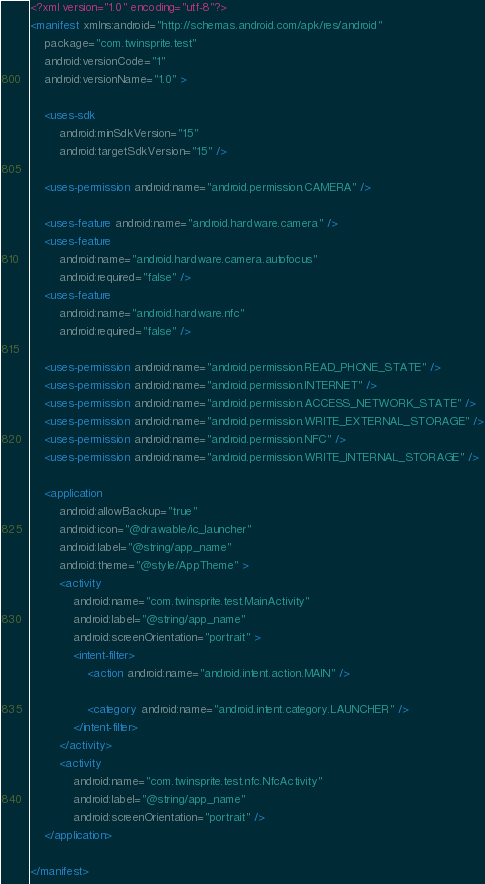<code> <loc_0><loc_0><loc_500><loc_500><_XML_><?xml version="1.0" encoding="utf-8"?>
<manifest xmlns:android="http://schemas.android.com/apk/res/android"
    package="com.twinsprite.test"
    android:versionCode="1"
    android:versionName="1.0" >

    <uses-sdk
        android:minSdkVersion="15"
        android:targetSdkVersion="15" />

    <uses-permission android:name="android.permission.CAMERA" />

    <uses-feature android:name="android.hardware.camera" />
    <uses-feature
        android:name="android.hardware.camera.autofocus"
        android:required="false" />
    <uses-feature
        android:name="android.hardware.nfc"
        android:required="false" />

    <uses-permission android:name="android.permission.READ_PHONE_STATE" />
    <uses-permission android:name="android.permission.INTERNET" />
    <uses-permission android:name="android.permission.ACCESS_NETWORK_STATE" />
    <uses-permission android:name="android.permission.WRITE_EXTERNAL_STORAGE" />
    <uses-permission android:name="android.permission.NFC" />
    <uses-permission android:name="android.permission.WRITE_INTERNAL_STORAGE" />

    <application
        android:allowBackup="true"
        android:icon="@drawable/ic_launcher"
        android:label="@string/app_name"
        android:theme="@style/AppTheme" >
        <activity
            android:name="com.twinsprite.test.MainActivity"
            android:label="@string/app_name"
            android:screenOrientation="portrait" >
            <intent-filter>
                <action android:name="android.intent.action.MAIN" />

                <category android:name="android.intent.category.LAUNCHER" />
            </intent-filter>
        </activity>
        <activity
            android:name="com.twinsprite.test.nfc.NfcActivity"
            android:label="@string/app_name"
            android:screenOrientation="portrait" />
    </application>

</manifest></code> 